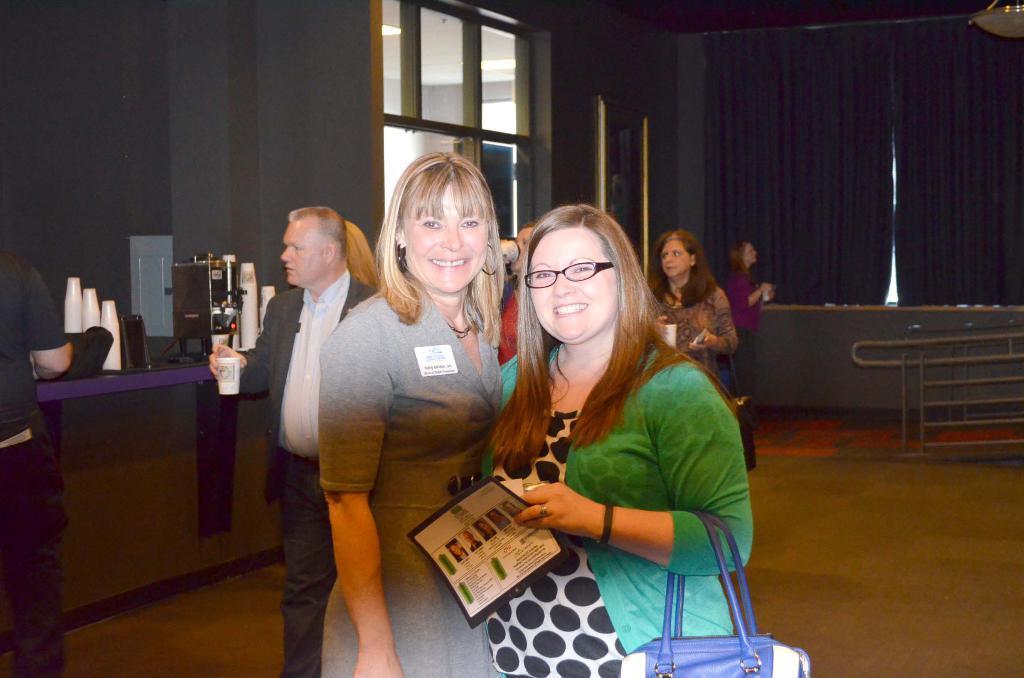In one or two sentences, can you explain what this image depicts? In this image I can see two persons standing, the person at right wearing green and black color dress and holding a blue color bag, the person at left wearing gray color dress. Background I can see few other persons walking holding a glass, I can also see a machine in black color. The wall and curtains in gray color. 